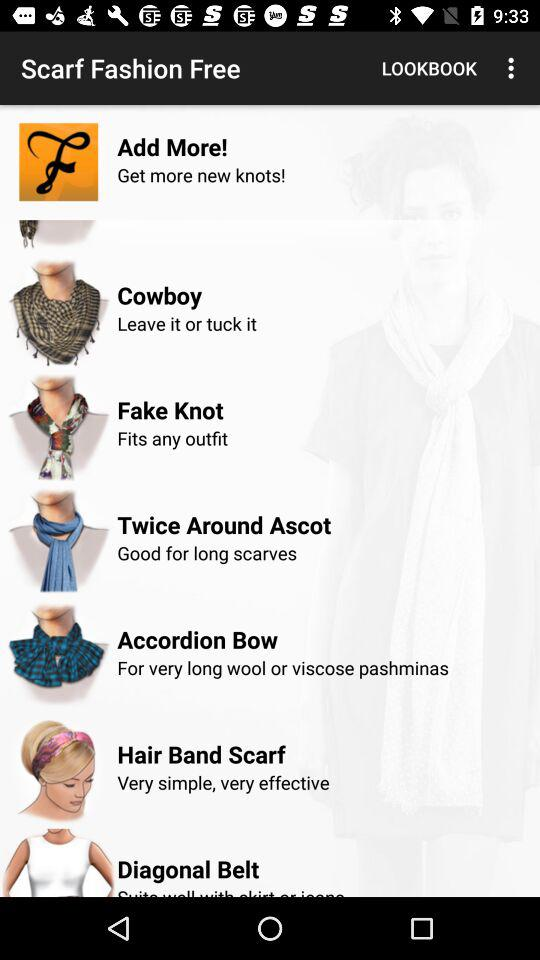Which scarf fashion fits any outfit? Scarf fashion that fits any outfit is "Fake Knot". 